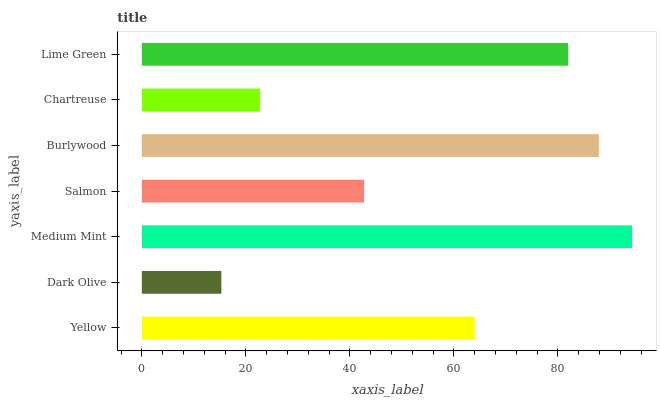Is Dark Olive the minimum?
Answer yes or no. Yes. Is Medium Mint the maximum?
Answer yes or no. Yes. Is Medium Mint the minimum?
Answer yes or no. No. Is Dark Olive the maximum?
Answer yes or no. No. Is Medium Mint greater than Dark Olive?
Answer yes or no. Yes. Is Dark Olive less than Medium Mint?
Answer yes or no. Yes. Is Dark Olive greater than Medium Mint?
Answer yes or no. No. Is Medium Mint less than Dark Olive?
Answer yes or no. No. Is Yellow the high median?
Answer yes or no. Yes. Is Yellow the low median?
Answer yes or no. Yes. Is Medium Mint the high median?
Answer yes or no. No. Is Dark Olive the low median?
Answer yes or no. No. 